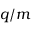<formula> <loc_0><loc_0><loc_500><loc_500>{ q } / { m }</formula> 